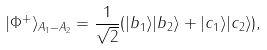Convert formula to latex. <formula><loc_0><loc_0><loc_500><loc_500>| \Phi ^ { + } \rangle _ { A _ { 1 } - A _ { 2 } } = \frac { 1 } { \sqrt { 2 } } ( | b _ { 1 } \rangle | b _ { 2 } \rangle + | c _ { 1 } \rangle | c _ { 2 } \rangle ) ,</formula> 